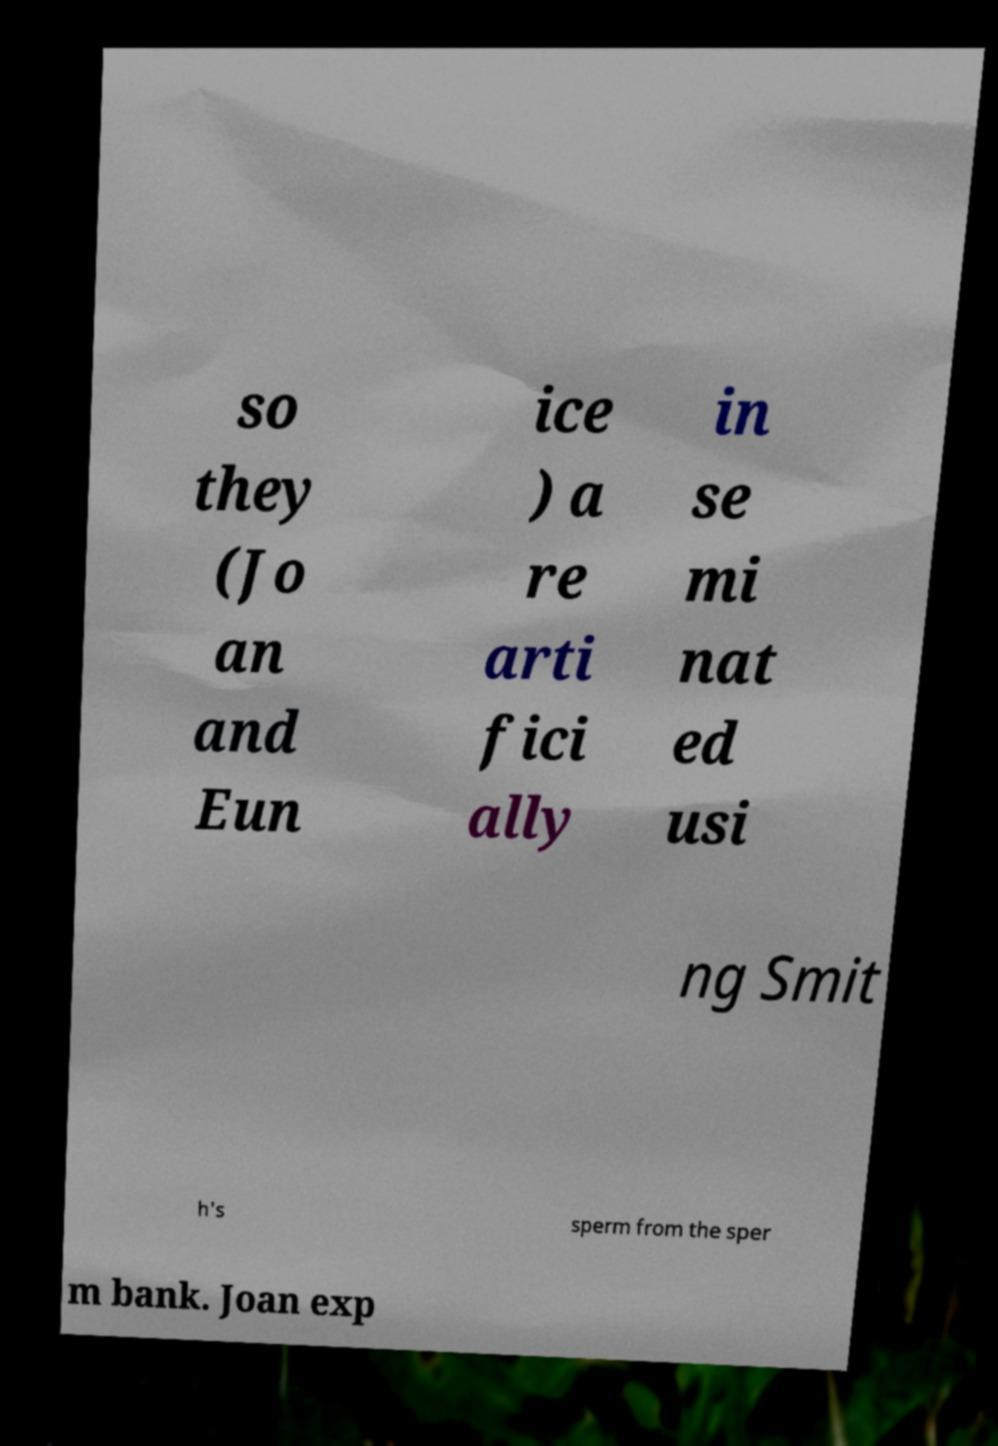Can you accurately transcribe the text from the provided image for me? so they (Jo an and Eun ice ) a re arti fici ally in se mi nat ed usi ng Smit h's sperm from the sper m bank. Joan exp 